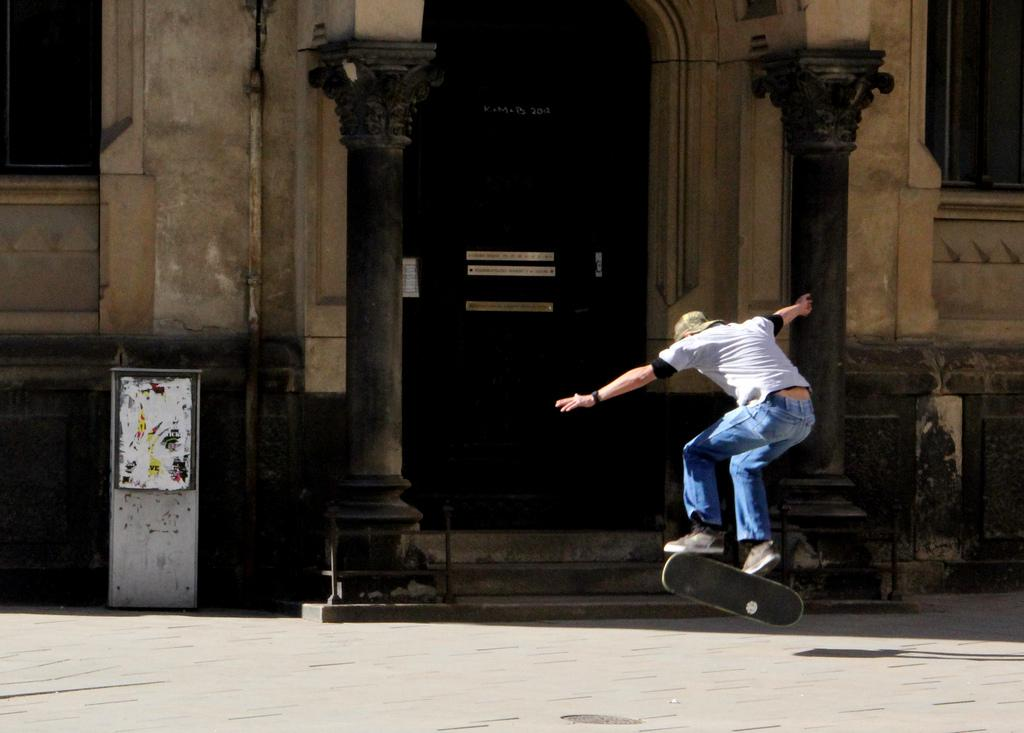Question: what is the man doing?
Choices:
A. Snowboarding.
B. Skiing.
C. Ice Skating.
D. Skateboarding.
Answer with the letter. Answer: D Question: who is in mid jump?
Choices:
A. A parachuter.
B. The snowboarder.
C. The track star.
D. The skateboarder.
Answer with the letter. Answer: D Question: what has large,black ornate columns?
Choices:
A. The temple.
B. The palace.
C. The building.
D. The restaurant.
Answer with the letter. Answer: C Question: what is the color the person's pants?
Choices:
A. White.
B. Blue.
C. Pink.
D. Black.
Answer with the letter. Answer: B Question: what gender is the person in the picture?
Choices:
A. Female.
B. Male.
C. Boy.
D. Girl.
Answer with the letter. Answer: B Question: what trick is he performing?
Choices:
A. Front flip.
B. Side winder.
C. Kickflip.
D. Back flip.
Answer with the letter. Answer: C Question: how many people are shown in this image?
Choices:
A. Two.
B. Four.
C. Six.
D. One.
Answer with the letter. Answer: D Question: why is the boy in the air?
Choices:
A. He was thrown.
B. On a trampoline.
C. He is jumping.
D. Jumped off a diving board.
Answer with the letter. Answer: C Question: who is wearing a white shirt?
Choices:
A. The skateboarder.
B. The punk rocker.
C. The woman running through the sprinklers.
D. The baby.
Answer with the letter. Answer: A Question: how many medal plates on the door?
Choices:
A. 4.
B. 3.
C. 0.
D. 6 business plates.
Answer with the letter. Answer: B Question: where does the scene take place?
Choices:
A. At an intersection.
B. In a castle.
C. In a store.
D. Along a city sidewalk.
Answer with the letter. Answer: D Question: what is the weather?
Choices:
A. Sunny.
B. Cloudy.
C. Rainy.
D. Windy.
Answer with the letter. Answer: A Question: who has his arms outstretched?
Choices:
A. The referee.
B. The father of the soldier.
C. The mother.
D. The man.
Answer with the letter. Answer: D Question: who is flipping the skateboard?
Choices:
A. The policeman.
B. The US team captain.
C. Mike.
D. The skateboarder.
Answer with the letter. Answer: D Question: who is skateboarding outside?
Choices:
A. The US skateboarding team.
B. A male.
C. The school kids.
D. Jenny Finch.
Answer with the letter. Answer: B Question: what color jeans is the man wearing?
Choices:
A. Blue.
B. Black.
C. Grey.
D. Brown.
Answer with the letter. Answer: A Question: when does the scene take place?
Choices:
A. Afternoon.
B. Daytime.
C. Evening.
D. At night.
Answer with the letter. Answer: B Question: how many decorative columns are on both sides of the door?
Choices:
A. 1.
B. 2.
C. 2 on each side.
D. 0.
Answer with the letter. Answer: B Question: what is the building made of?
Choices:
A. Brick.
B. Metal.
C. Stone.
D. Plastic.
Answer with the letter. Answer: C 